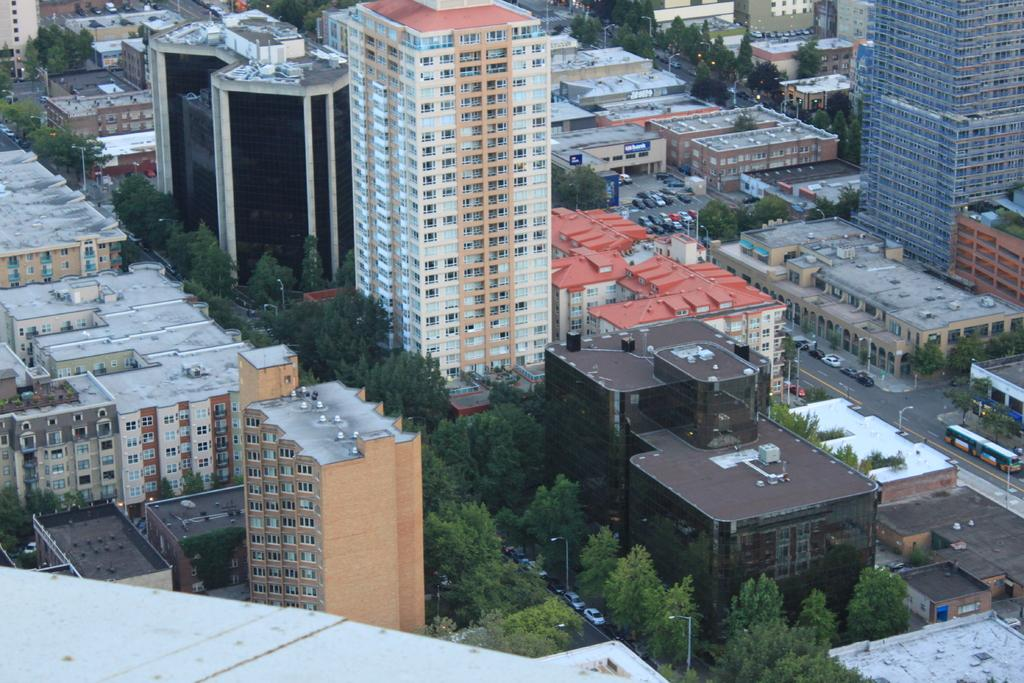What type of structures can be seen in the image? There are many buildings in the image. What other elements can be found in the image besides buildings? There are trees in the image. Are there any vehicles visible in the image? Yes, there are cars visible on the road in the image. What type of cart can be seen in the image? There is no cart present in the image. What is the interest rate for the loan mentioned in the image? There is no mention of a loan or interest rate in the image. 